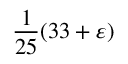<formula> <loc_0><loc_0><loc_500><loc_500>{ \frac { 1 } { 2 5 } } ( 3 3 + \varepsilon )</formula> 